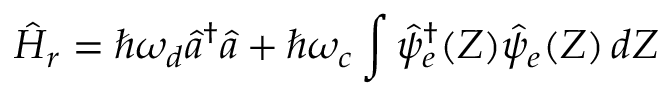Convert formula to latex. <formula><loc_0><loc_0><loc_500><loc_500>\hat { H } _ { r } = \hbar { \omega } _ { d } \hat { a } ^ { \dagger } \hat { a } + \hbar { \omega } _ { c } \int \hat { \psi } _ { e } ^ { \dagger } ( Z ) \hat { \psi } _ { e } ( Z ) \, d Z</formula> 